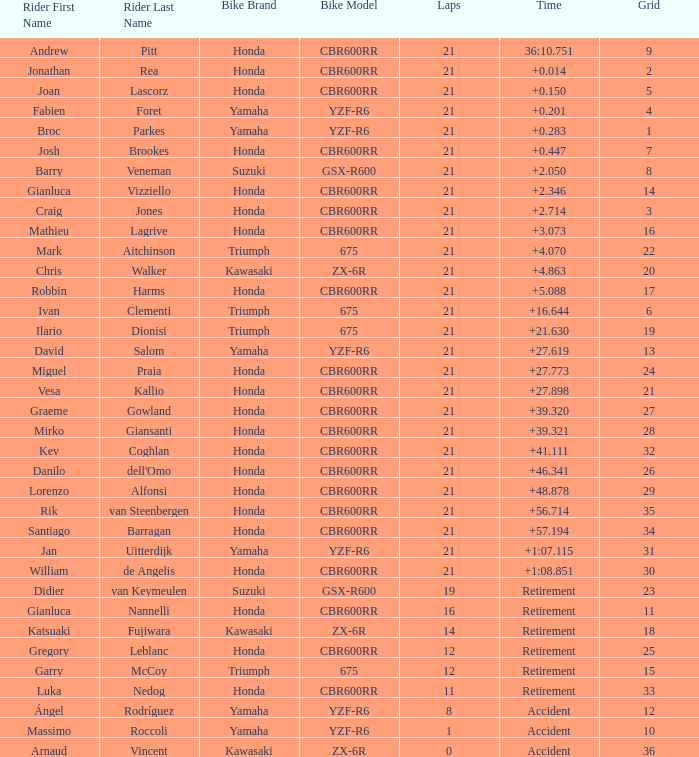What driver had the highest grid position with a time of +0.283? 1.0. 